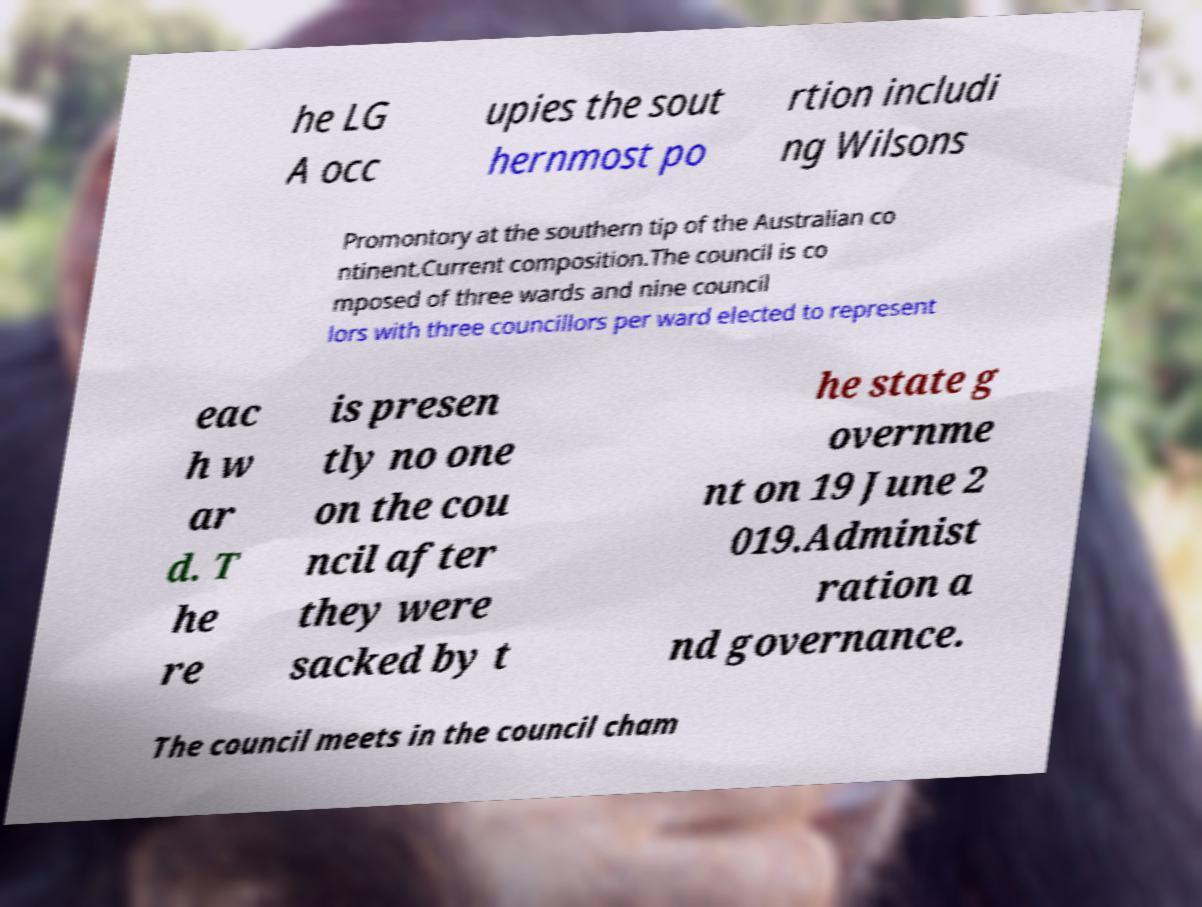Can you read and provide the text displayed in the image?This photo seems to have some interesting text. Can you extract and type it out for me? he LG A occ upies the sout hernmost po rtion includi ng Wilsons Promontory at the southern tip of the Australian co ntinent.Current composition.The council is co mposed of three wards and nine council lors with three councillors per ward elected to represent eac h w ar d. T he re is presen tly no one on the cou ncil after they were sacked by t he state g overnme nt on 19 June 2 019.Administ ration a nd governance. The council meets in the council cham 